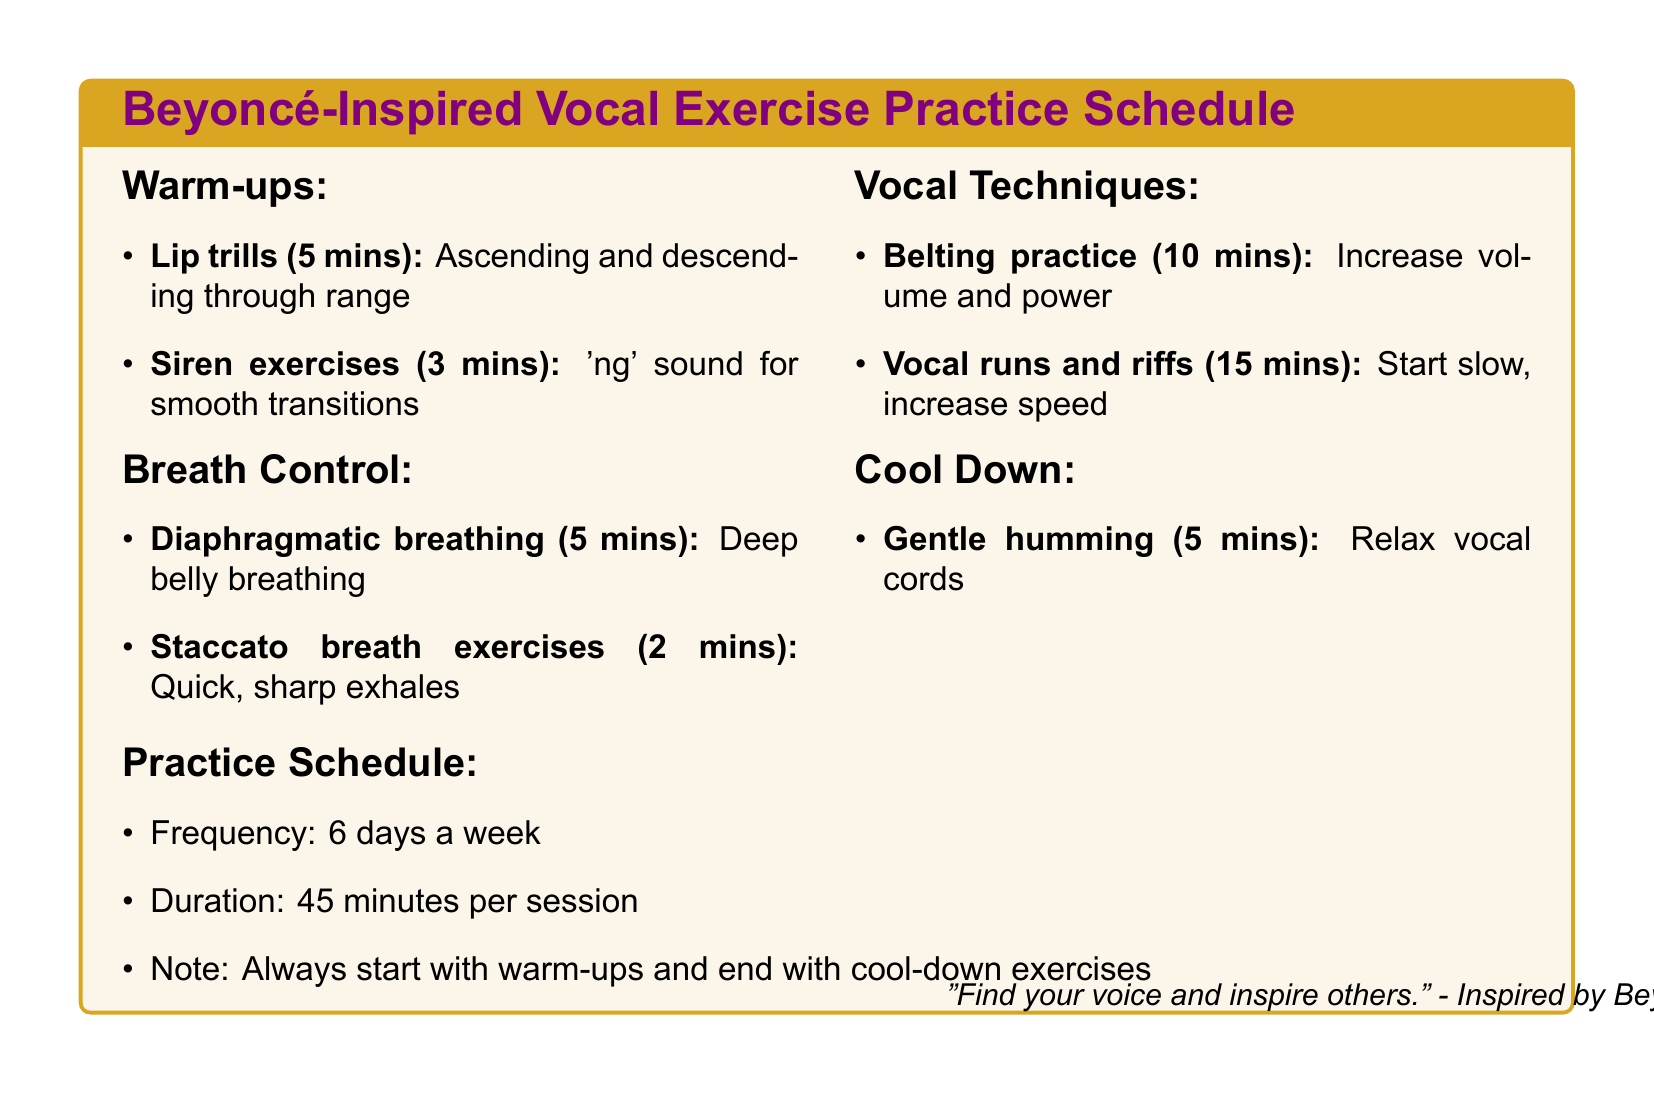What is the title of the document? The title is specified at the top of the document to provide context.
Answer: Beyoncé-Inspired Vocal Exercise Practice Schedule How many minutes should be spent on belting practice? The document lists the duration of each vocal technique under Vocal Techniques.
Answer: 10 minutes Which warm-up exercise does Beyoncé often use before performances? The explanation includes a connection between the exercise and Beyoncé's practices mentioned in the warm-up section.
Answer: Lip trills What is the total duration of a practice session? The duration specified in the practice schedule section outlines the time required for each session.
Answer: 45 minutes How many days a week is the practice schedule recommended for? The frequency provided in the practice schedule indicates how often to practice.
Answer: 6 days a week What type of breathing exercise is recommended for breath control? The document describes specific exercises under the breath control section, pointing out diaphragmatic breathing as a key exercise.
Answer: Diaphragmatic breathing What is the purpose of gentle humming at the end of the practice session? The cool-down exercise provides a rationale for its use, connecting it to vocal health.
Answer: Relax vocal cords Which Beyoncé song features rapid vocal runs that require precise breath control? The document references specific songs linked to vocal techniques for context.
Answer: Crazy in Love What is the main focus of the practice schedule? The document emphasizes the importance of a structured approach to these vocal exercises.
Answer: Protect your voice 